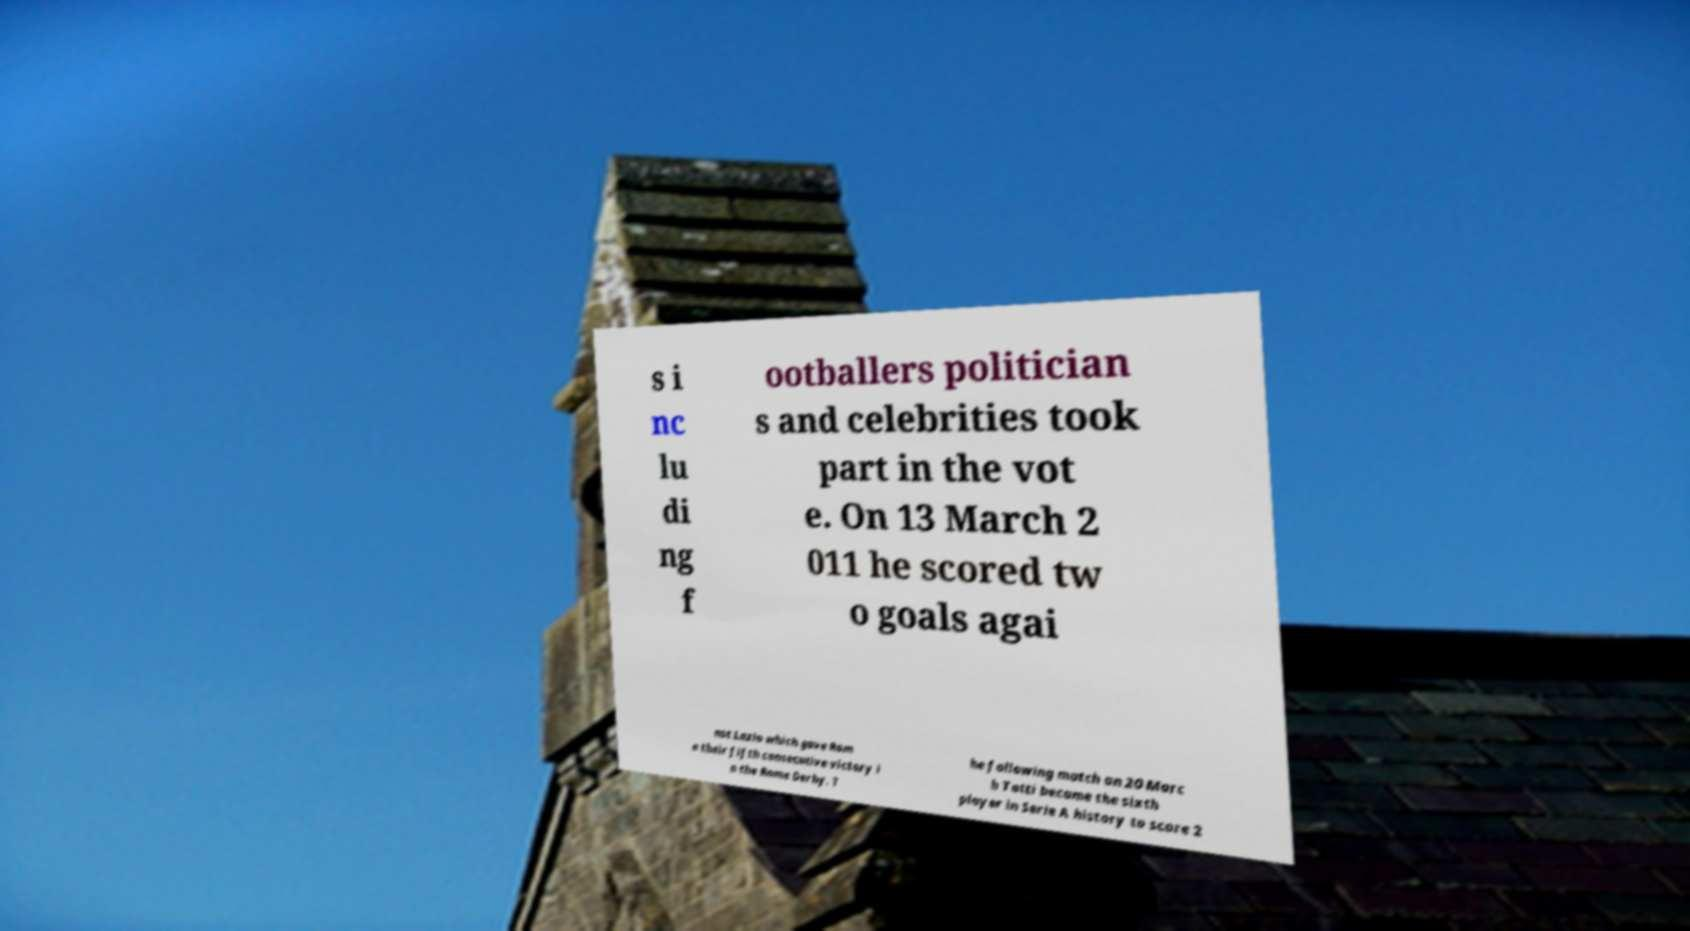Can you accurately transcribe the text from the provided image for me? s i nc lu di ng f ootballers politician s and celebrities took part in the vot e. On 13 March 2 011 he scored tw o goals agai nst Lazio which gave Rom a their fifth consecutive victory i n the Rome Derby. T he following match on 20 Marc h Totti became the sixth player in Serie A history to score 2 